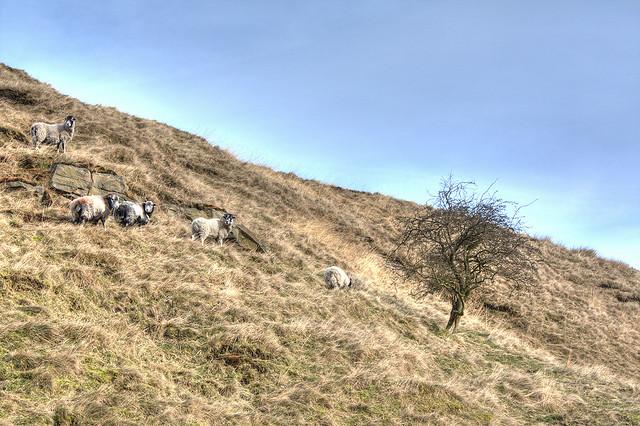How many trees are in the image?
Be succinct. 1. What are the animals?
Be succinct. Sheep. Is the sky clear?
Keep it brief. Yes. Any animals in this picture?
Quick response, please. Yes. 